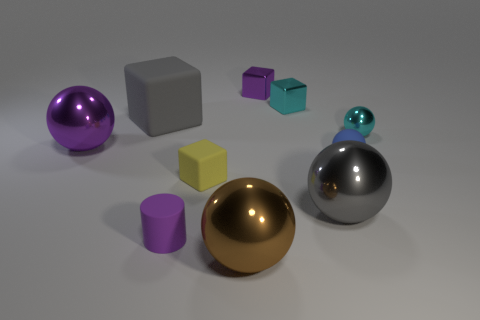Subtract all tiny cubes. How many cubes are left? 1 Subtract all yellow blocks. How many blocks are left? 3 Subtract all blocks. How many objects are left? 6 Subtract 3 blocks. How many blocks are left? 1 Add 5 purple objects. How many purple objects exist? 8 Subtract 0 gray cylinders. How many objects are left? 10 Subtract all yellow cylinders. Subtract all gray spheres. How many cylinders are left? 1 Subtract all small cyan matte objects. Subtract all gray objects. How many objects are left? 8 Add 4 small purple metallic objects. How many small purple metallic objects are left? 5 